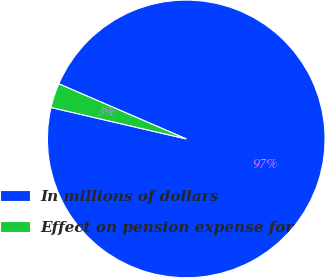Convert chart to OTSL. <chart><loc_0><loc_0><loc_500><loc_500><pie_chart><fcel>In millions of dollars<fcel>Effect on pension expense for<nl><fcel>97.14%<fcel>2.86%<nl></chart> 